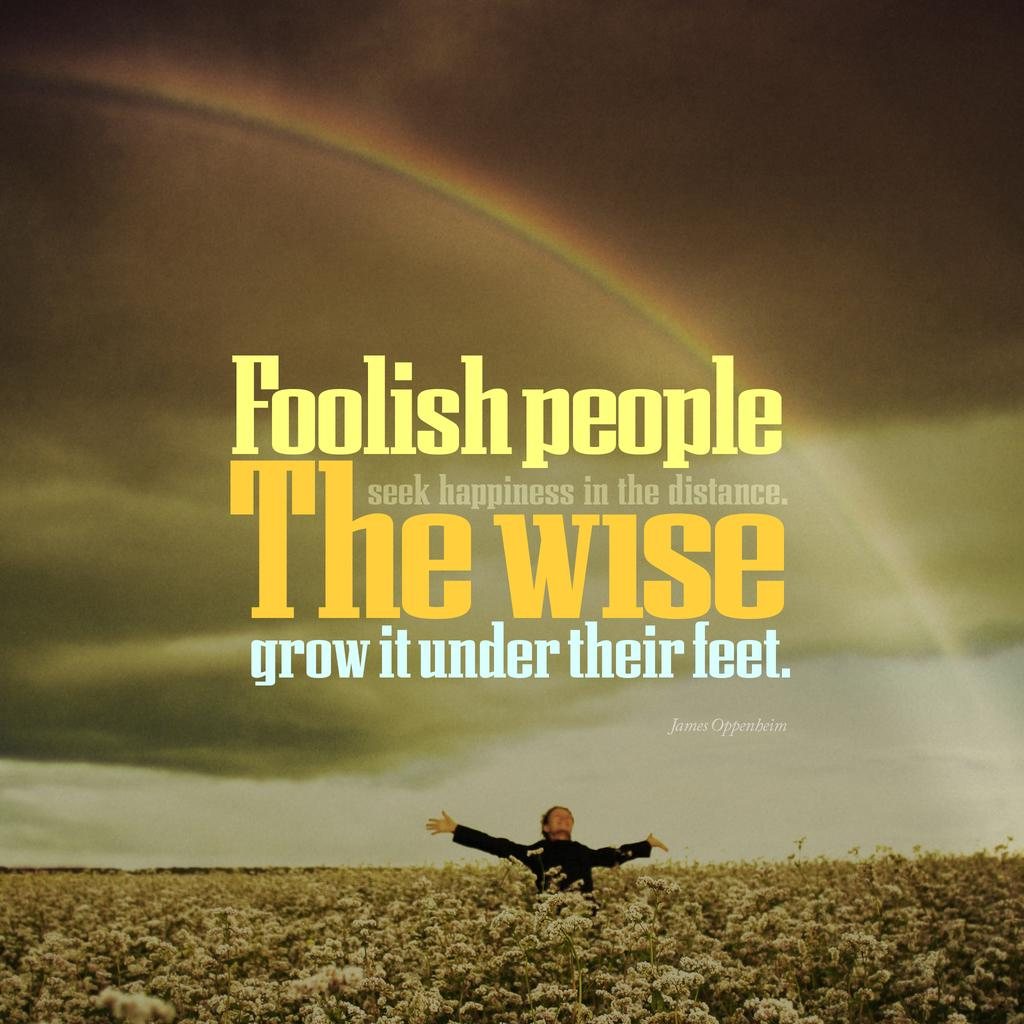<image>
Describe the image concisely. A person in a field with a rainbow and the quote foolish people seek happiness in the distance. 